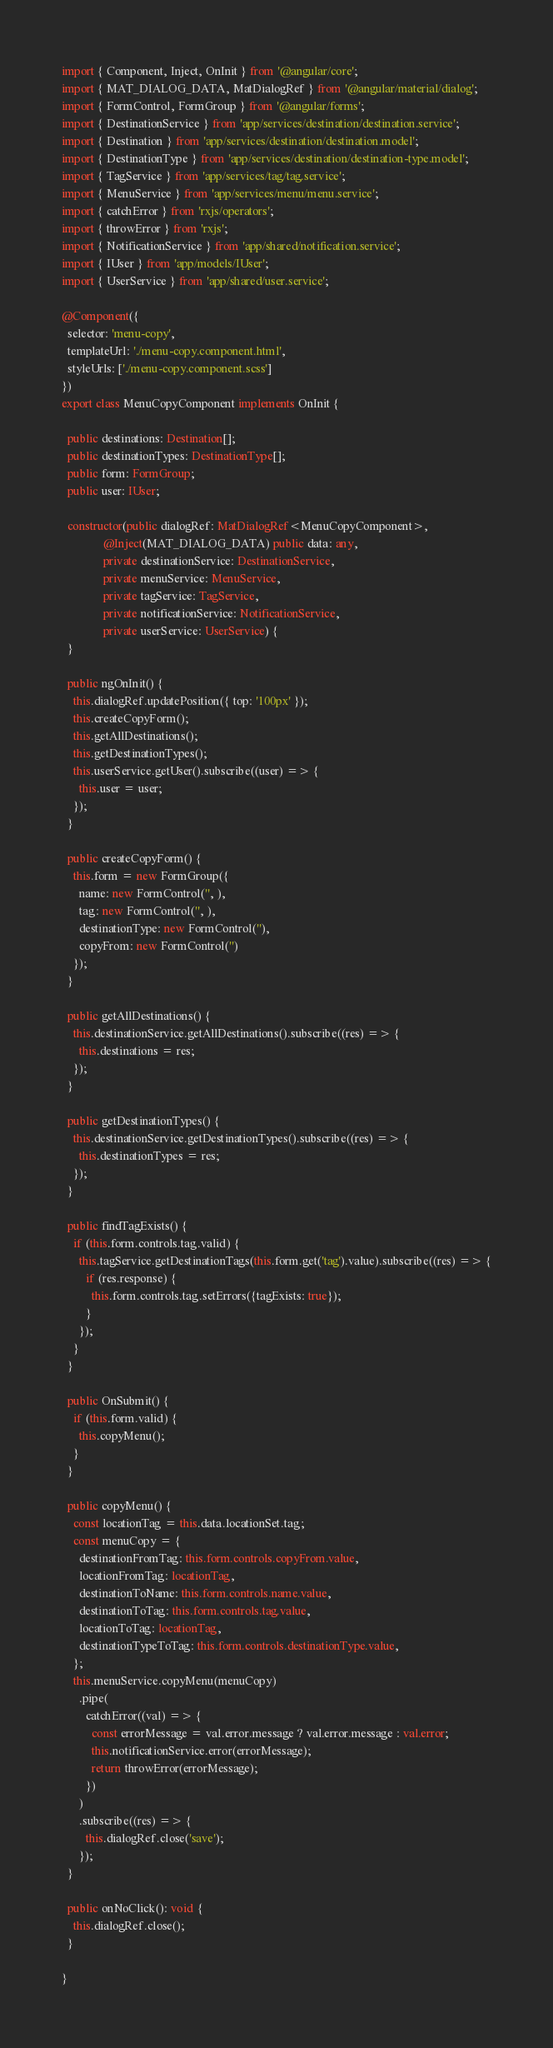Convert code to text. <code><loc_0><loc_0><loc_500><loc_500><_TypeScript_>import { Component, Inject, OnInit } from '@angular/core';
import { MAT_DIALOG_DATA, MatDialogRef } from '@angular/material/dialog';
import { FormControl, FormGroup } from '@angular/forms';
import { DestinationService } from 'app/services/destination/destination.service';
import { Destination } from 'app/services/destination/destination.model';
import { DestinationType } from 'app/services/destination/destination-type.model';
import { TagService } from 'app/services/tag/tag.service';
import { MenuService } from 'app/services/menu/menu.service';
import { catchError } from 'rxjs/operators';
import { throwError } from 'rxjs';
import { NotificationService } from 'app/shared/notification.service';
import { IUser } from 'app/models/IUser';
import { UserService } from 'app/shared/user.service';

@Component({
  selector: 'menu-copy',
  templateUrl: './menu-copy.component.html',
  styleUrls: ['./menu-copy.component.scss']
})
export class MenuCopyComponent implements OnInit {

  public destinations: Destination[];
  public destinationTypes: DestinationType[];
  public form: FormGroup;
  public user: IUser;

  constructor(public dialogRef: MatDialogRef<MenuCopyComponent>,
              @Inject(MAT_DIALOG_DATA) public data: any,
              private destinationService: DestinationService,
              private menuService: MenuService,
              private tagService: TagService,
              private notificationService: NotificationService,
              private userService: UserService) {
  }

  public ngOnInit() {
    this.dialogRef.updatePosition({ top: '100px' });
    this.createCopyForm();
    this.getAllDestinations();
    this.getDestinationTypes();
    this.userService.getUser().subscribe((user) => {
      this.user = user;
    });
  }

  public createCopyForm() {
    this.form = new FormGroup({
      name: new FormControl('', ),
      tag: new FormControl('', ),
      destinationType: new FormControl(''),
      copyFrom: new FormControl('')
    });
  }

  public getAllDestinations() {
    this.destinationService.getAllDestinations().subscribe((res) => {
      this.destinations = res;
    });
  }

  public getDestinationTypes() {
    this.destinationService.getDestinationTypes().subscribe((res) => {
      this.destinationTypes = res;
    });
  }

  public findTagExists() {
    if (this.form.controls.tag.valid) {
      this.tagService.getDestinationTags(this.form.get('tag').value).subscribe((res) => {
        if (res.response) {
          this.form.controls.tag.setErrors({tagExists: true});
        }
      });
    }
  }

  public OnSubmit() {
    if (this.form.valid) {
      this.copyMenu();
    }
  }

  public copyMenu() {
    const locationTag = this.data.locationSet.tag;
    const menuCopy = {
      destinationFromTag: this.form.controls.copyFrom.value,
      locationFromTag: locationTag,
      destinationToName: this.form.controls.name.value,
      destinationToTag: this.form.controls.tag.value,
      locationToTag: locationTag,
      destinationTypeToTag: this.form.controls.destinationType.value,
    };
    this.menuService.copyMenu(menuCopy)
      .pipe(
        catchError((val) => {
          const errorMessage = val.error.message ? val.error.message : val.error;
          this.notificationService.error(errorMessage);
          return throwError(errorMessage);
        })
      )
      .subscribe((res) => {
        this.dialogRef.close('save');
      });
  }

  public onNoClick(): void {
    this.dialogRef.close();
  }

}
</code> 